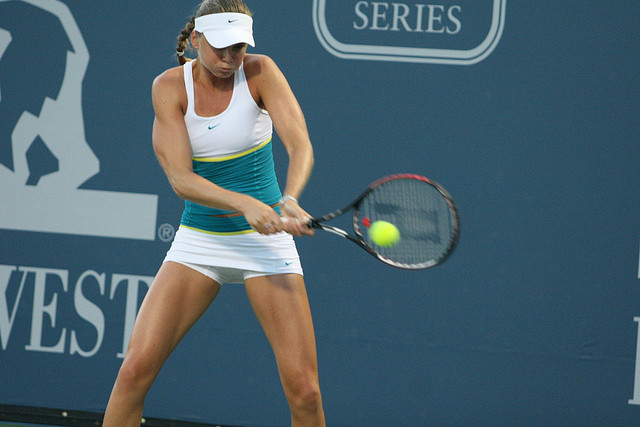Please transcribe the text in this image. SERIES WEST 